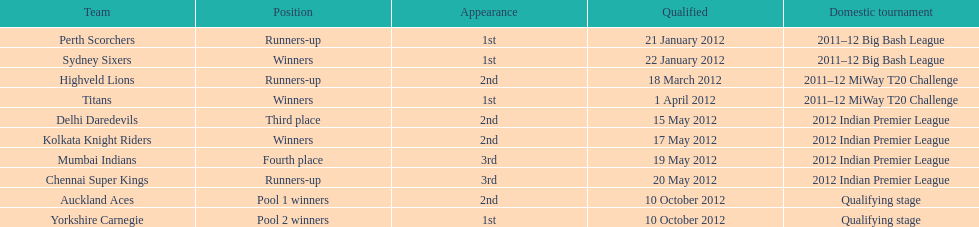Did the titans or the daredevils winners? Titans. 